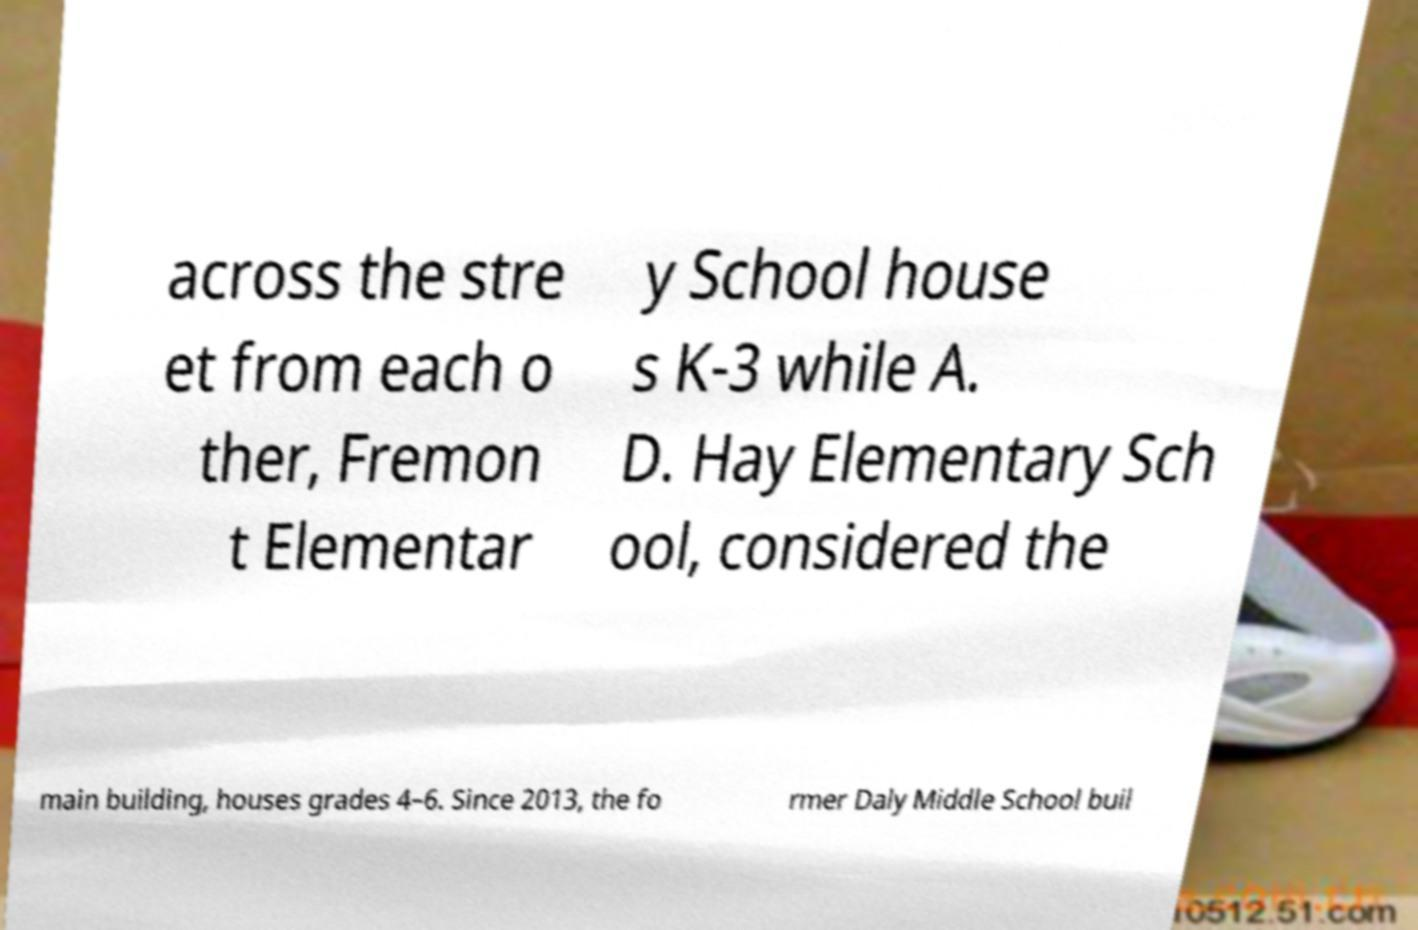There's text embedded in this image that I need extracted. Can you transcribe it verbatim? across the stre et from each o ther, Fremon t Elementar y School house s K-3 while A. D. Hay Elementary Sch ool, considered the main building, houses grades 4–6. Since 2013, the fo rmer Daly Middle School buil 